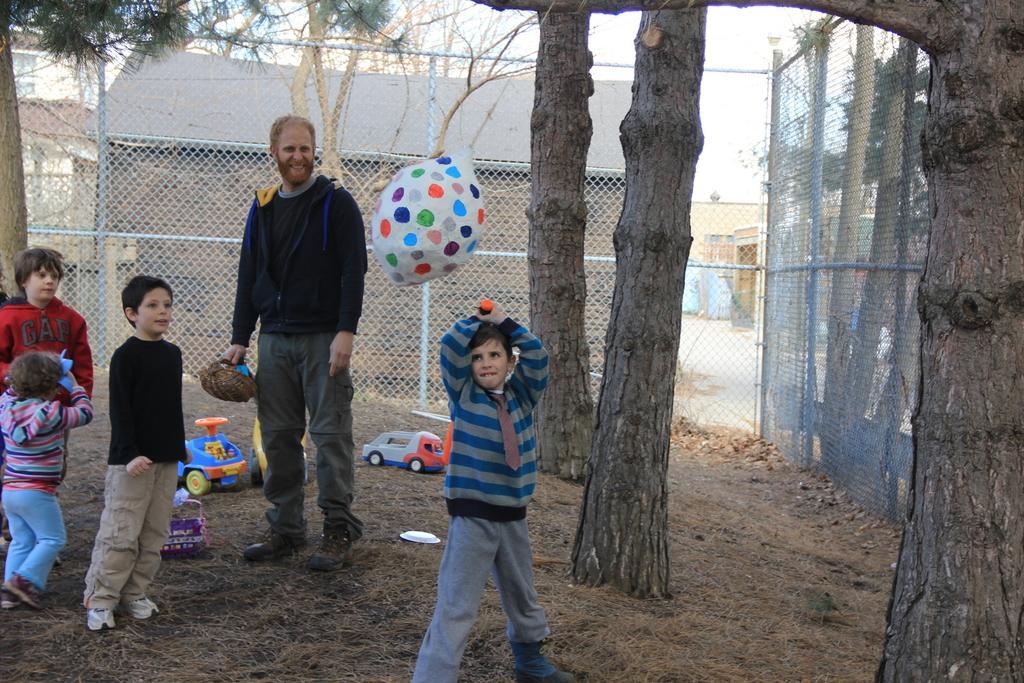Please provide a concise description of this image. In this picture we can see a group of people on the ground and in the background we can see a fence,trees. 